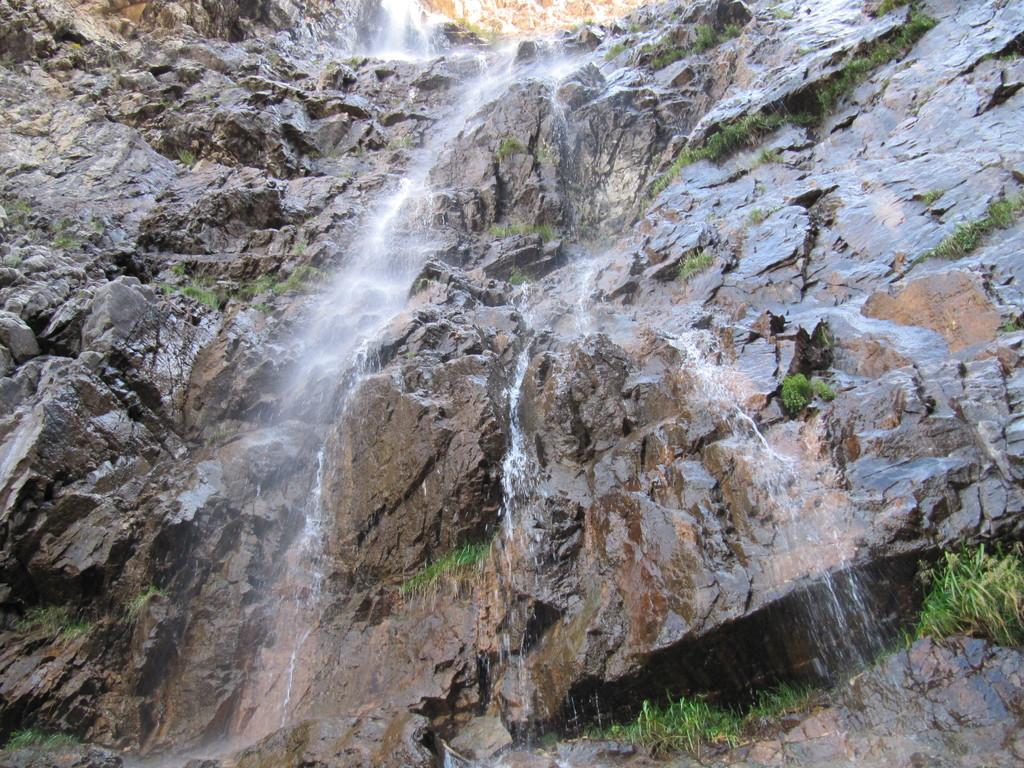What type of natural formation is present in the image? There is a mountain rock in the image. What can be seen flowing near the mountain rock? There is a waterfall in the image. What type of plant is growing on the mark in the image? There is no mark or plant present in the image; it features a mountain rock and a waterfall. 